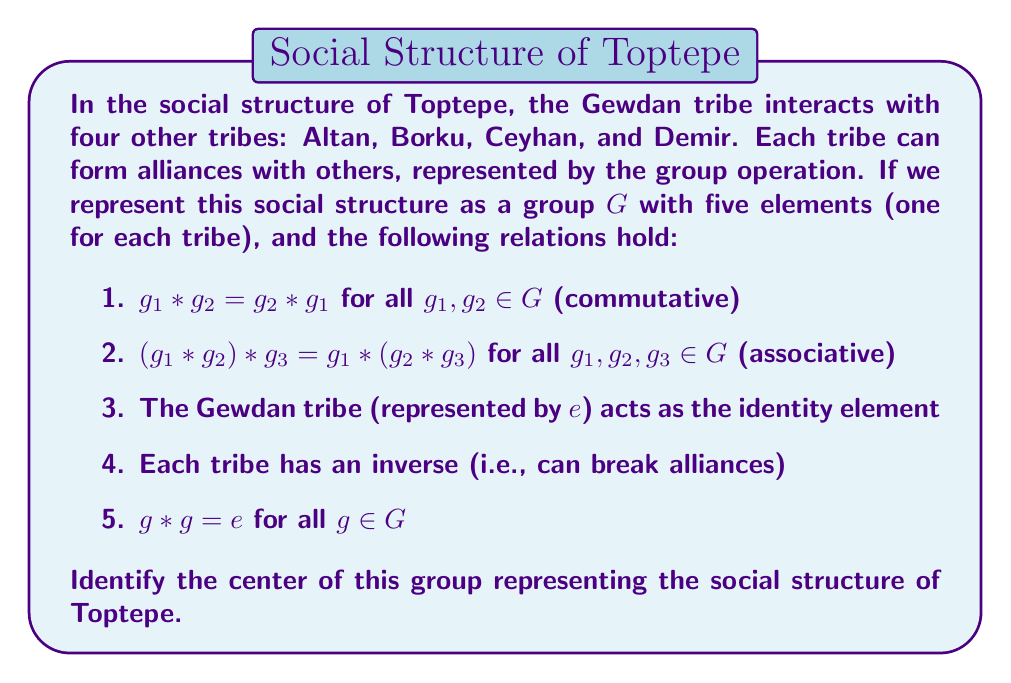Can you answer this question? To solve this problem, let's follow these steps:

1) First, recall that the center of a group $G$ is defined as:
   $$Z(G) = \{a \in G : ag = ga \text{ for all } g \in G\}$$

2) From the given information, we can deduce that this group is isomorphic to the Klein four-group $V_4$ along with an additional element (the identity $e$). This makes it isomorphic to $\mathbb{Z}_2 \times \mathbb{Z}_2 \times \mathbb{Z}_2$.

3) In this group structure:
   - The identity element $e$ (representing the Gewdan tribe) commutes with all elements.
   - For any other element $g \in G$, we have $g * g = e$.
   - The group is abelian (commutative), as stated in condition 1.

4) Since the group is abelian, every element commutes with every other element. This means that for all $a, g \in G$, we have $ag = ga$.

5) By the definition of the center, this implies that every element of the group is in the center.

Therefore, the center of this group is the entire group itself.
Answer: $Z(G) = G$ 